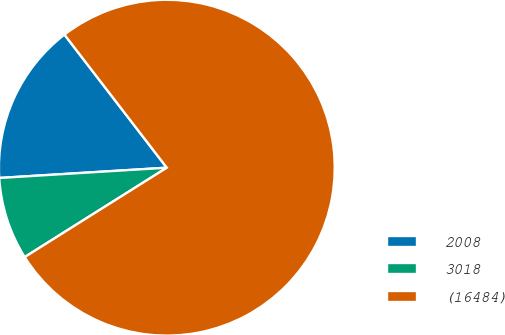<chart> <loc_0><loc_0><loc_500><loc_500><pie_chart><fcel>2008<fcel>3018<fcel>(16484)<nl><fcel>15.54%<fcel>7.96%<fcel>76.5%<nl></chart> 